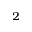<formula> <loc_0><loc_0><loc_500><loc_500>_ { 2 }</formula> 